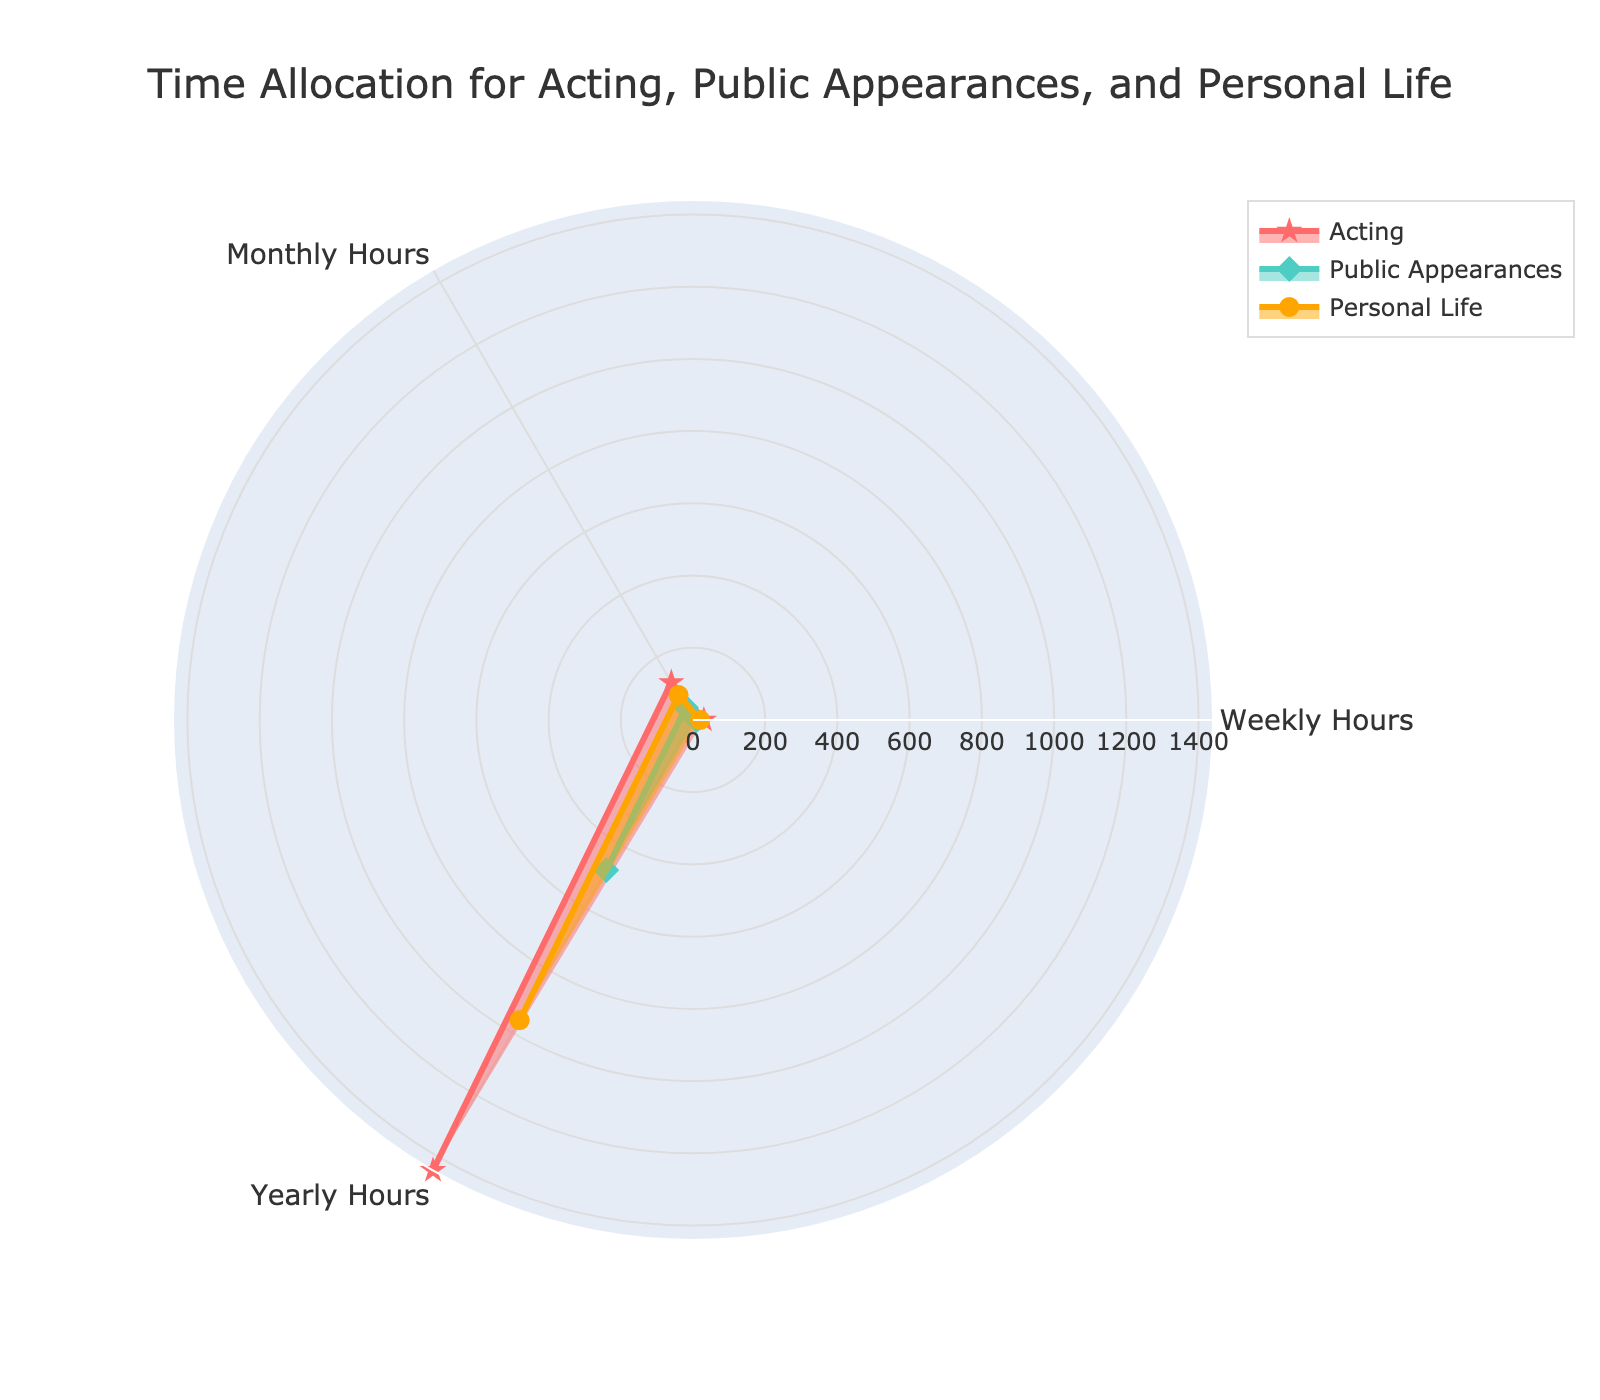Which category has the highest yearly hours for Acting? By checking the plot, the year category shows the highest yearly hours value for Acting compared to weekly and monthly values.
Answer: Yearly Hours What is the range of hours spent on Personal Life in the graph? The range can be determined by taking the difference between the maximum and minimum values of Personal Life across the categories. The max value is 960 (Yearly) and the min value is 20 (Weekly), so the range is 960 - 20.
Answer: 940 Which activity has the least time allocation in the weekly category? By examining the weekly hours' data points, we see that Public Appearances has the lowest value of 10 hours.
Answer: Public Appearances Is the time allocated to Acting more or less than the time allocated to Personal Life in monthly hours? The monthly hours for Acting are 120 while for Personal Life it is 80. Since 120 is greater than 80, the time allocated to Acting is more.
Answer: More How much more time is allocated to Acting than to Public Appearances in yearly hours? Subtract the yearly hours for Public Appearances from Acting: 1440 - 480 = 960.
Answer: 960 What is the total time spent on Public Appearances across all categories? Sum up the hours spent on Public Appearances for weekly, monthly, and yearly categories: 10 + 40 + 480 = 530.
Answer: 530 Compare the hours spent on Personal Life and Public Appearances in the monthly category and state by how much they differ. The monthly hours for Personal Life are 80 and for Public Appearances are 40. The difference is 80 - 40.
Answer: 40 What is the average time spent on Acting per week in a year? There are 52 weeks in a year. Divide the yearly hours spent on Acting by the number of weeks: 1440 / 52 = approximately 27.69.
Answer: ~27.69 What is the ratio of weekly hours spent on Acting to weekly hours spent on Public Appearances? Divide the weekly hours spent on Acting by the weekly hours spent on Public Appearances: 30 / 10 = 3.
Answer: 3 Which category shows the least variation in time allocation between the three activities? By comparing the differences within each category across activities, the weekly category shows the least variation between the activities (30-10 and 30-20).
Answer: Weekly 